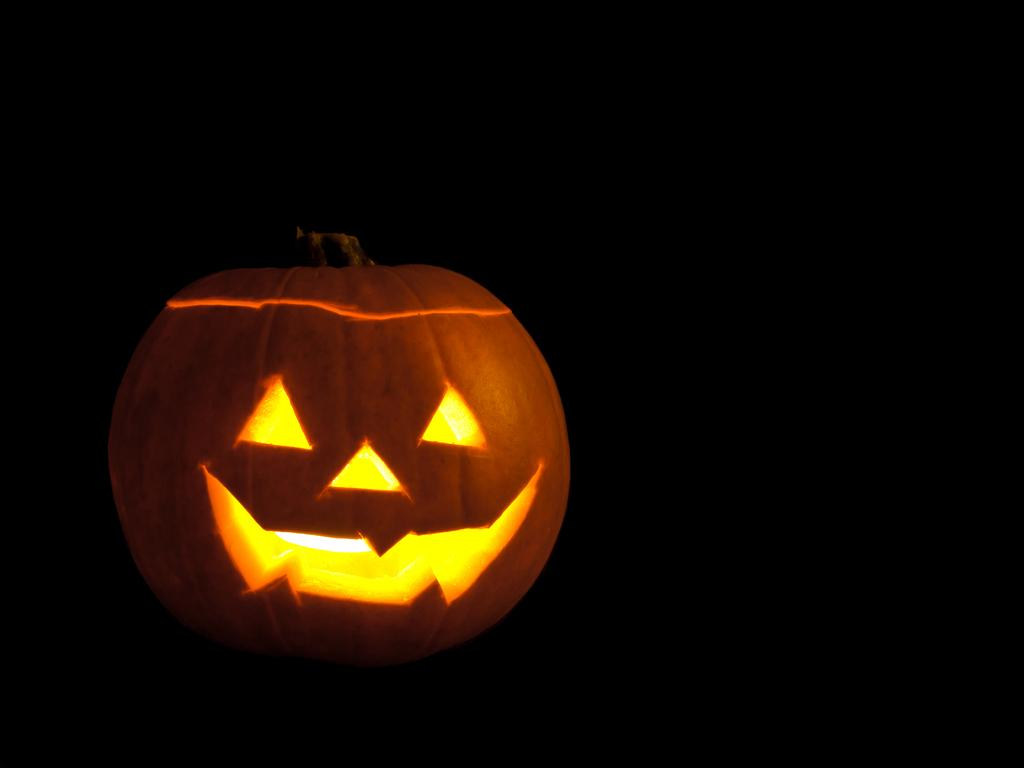What is the main subject of the picture? The main subject of the picture is a pumpkin. Does the pumpkin have any unique features? Yes, the pumpkin has a design on it. What can be observed about the overall appearance of the image? The background of the image is dark. What type of screw can be seen holding the apparel together in the image? There is no screw or apparel present in the image; it features a pumpkin with a design on it against a dark background. How much debt is visible in the image? There is no reference to debt in the image, as it only contains a pumpkin with a design on it and a dark background. 